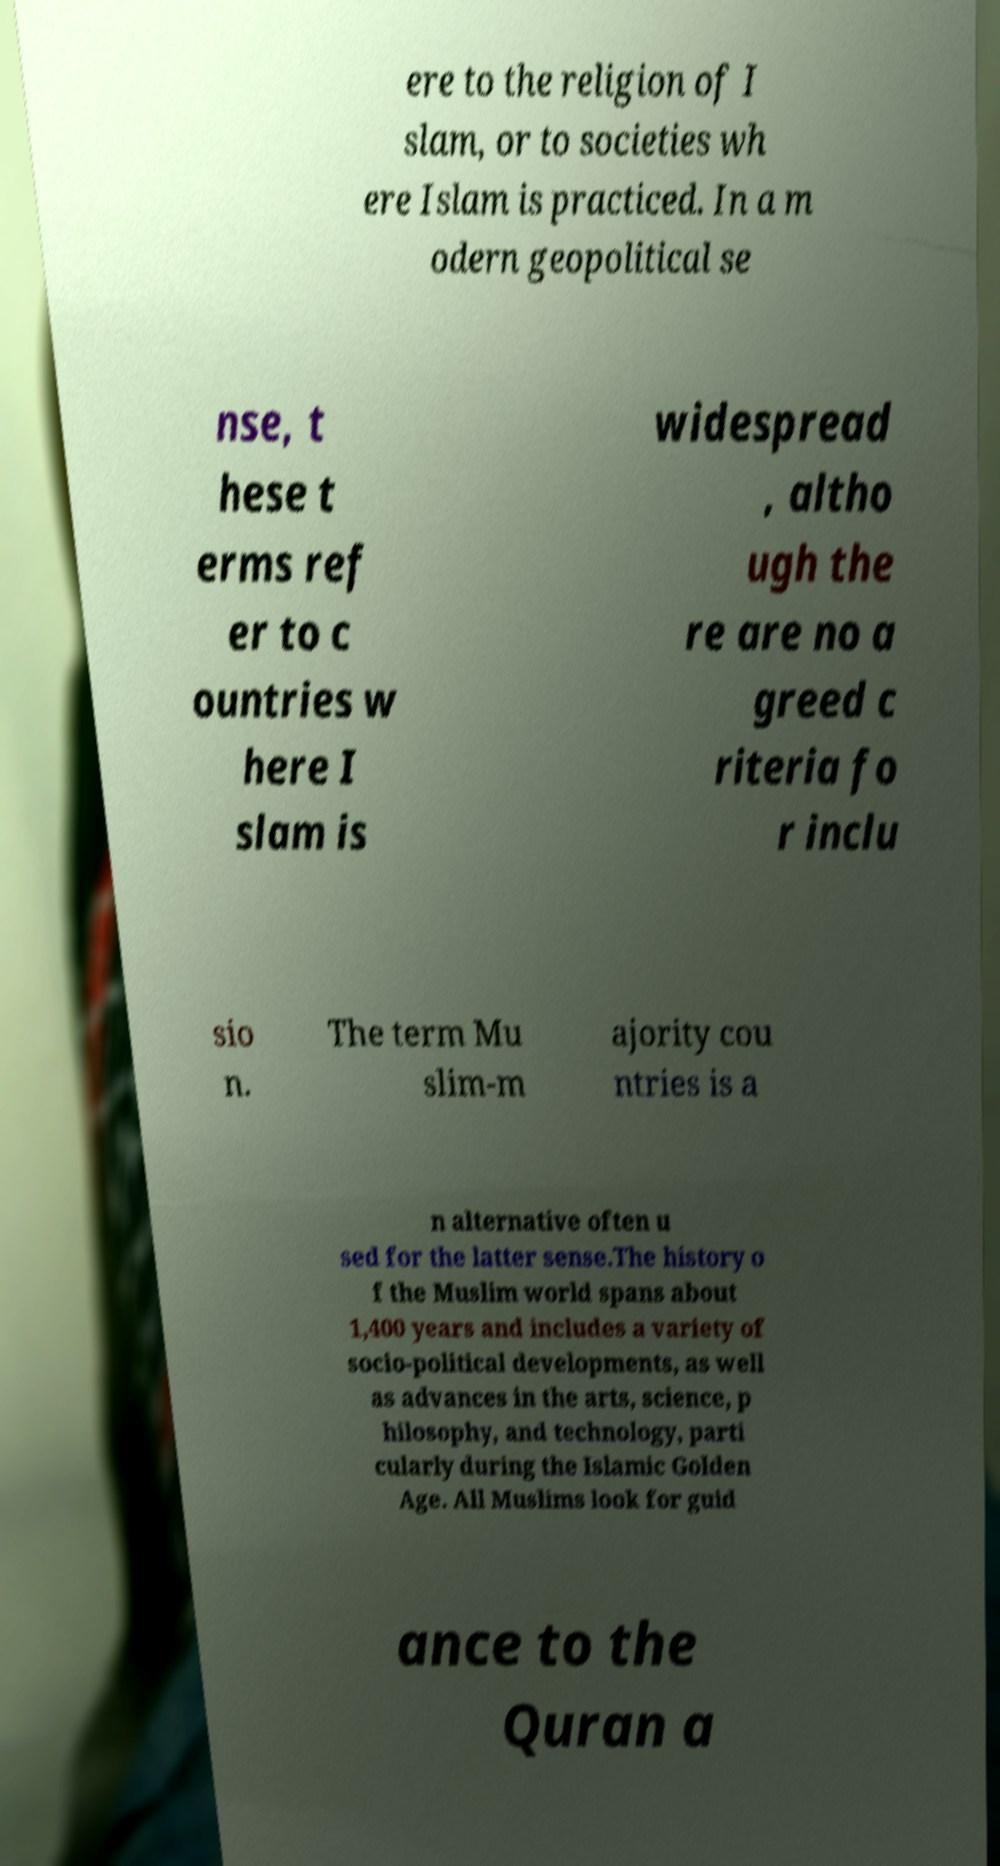Could you assist in decoding the text presented in this image and type it out clearly? ere to the religion of I slam, or to societies wh ere Islam is practiced. In a m odern geopolitical se nse, t hese t erms ref er to c ountries w here I slam is widespread , altho ugh the re are no a greed c riteria fo r inclu sio n. The term Mu slim-m ajority cou ntries is a n alternative often u sed for the latter sense.The history o f the Muslim world spans about 1,400 years and includes a variety of socio-political developments, as well as advances in the arts, science, p hilosophy, and technology, parti cularly during the Islamic Golden Age. All Muslims look for guid ance to the Quran a 